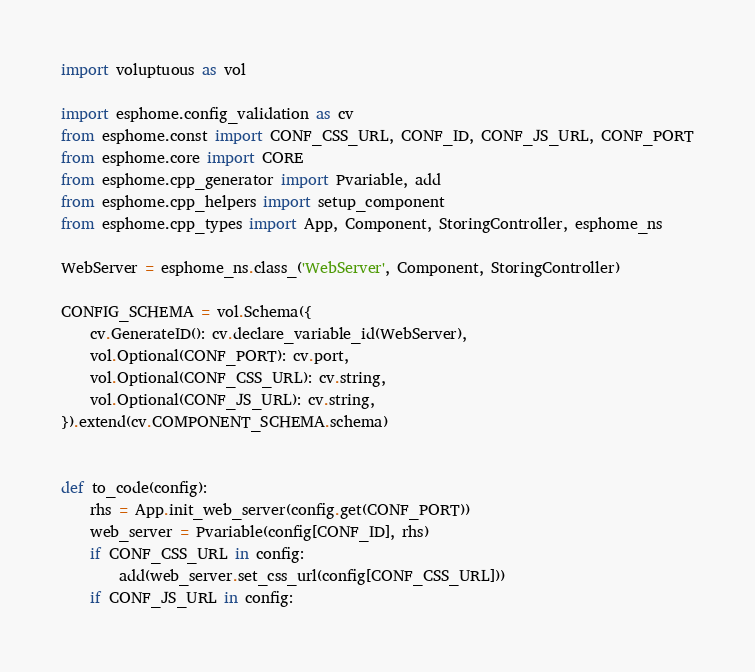<code> <loc_0><loc_0><loc_500><loc_500><_Python_>import voluptuous as vol

import esphome.config_validation as cv
from esphome.const import CONF_CSS_URL, CONF_ID, CONF_JS_URL, CONF_PORT
from esphome.core import CORE
from esphome.cpp_generator import Pvariable, add
from esphome.cpp_helpers import setup_component
from esphome.cpp_types import App, Component, StoringController, esphome_ns

WebServer = esphome_ns.class_('WebServer', Component, StoringController)

CONFIG_SCHEMA = vol.Schema({
    cv.GenerateID(): cv.declare_variable_id(WebServer),
    vol.Optional(CONF_PORT): cv.port,
    vol.Optional(CONF_CSS_URL): cv.string,
    vol.Optional(CONF_JS_URL): cv.string,
}).extend(cv.COMPONENT_SCHEMA.schema)


def to_code(config):
    rhs = App.init_web_server(config.get(CONF_PORT))
    web_server = Pvariable(config[CONF_ID], rhs)
    if CONF_CSS_URL in config:
        add(web_server.set_css_url(config[CONF_CSS_URL]))
    if CONF_JS_URL in config:</code> 